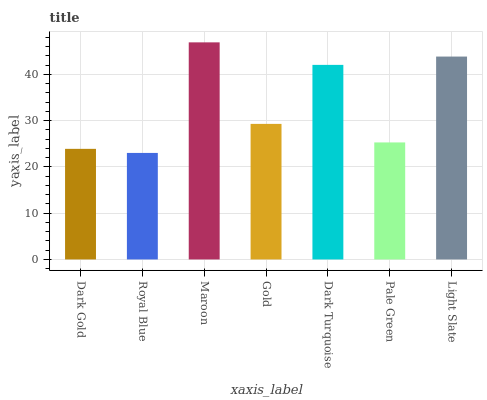Is Maroon the minimum?
Answer yes or no. No. Is Royal Blue the maximum?
Answer yes or no. No. Is Maroon greater than Royal Blue?
Answer yes or no. Yes. Is Royal Blue less than Maroon?
Answer yes or no. Yes. Is Royal Blue greater than Maroon?
Answer yes or no. No. Is Maroon less than Royal Blue?
Answer yes or no. No. Is Gold the high median?
Answer yes or no. Yes. Is Gold the low median?
Answer yes or no. Yes. Is Dark Turquoise the high median?
Answer yes or no. No. Is Light Slate the low median?
Answer yes or no. No. 